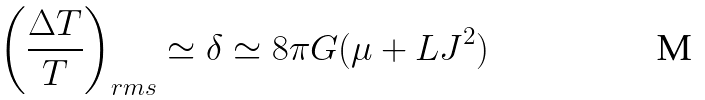Convert formula to latex. <formula><loc_0><loc_0><loc_500><loc_500>\left ( \frac { \Delta T } { T } \right ) _ { r m s } \simeq \delta \simeq 8 \pi G ( \mu + L J ^ { 2 } )</formula> 